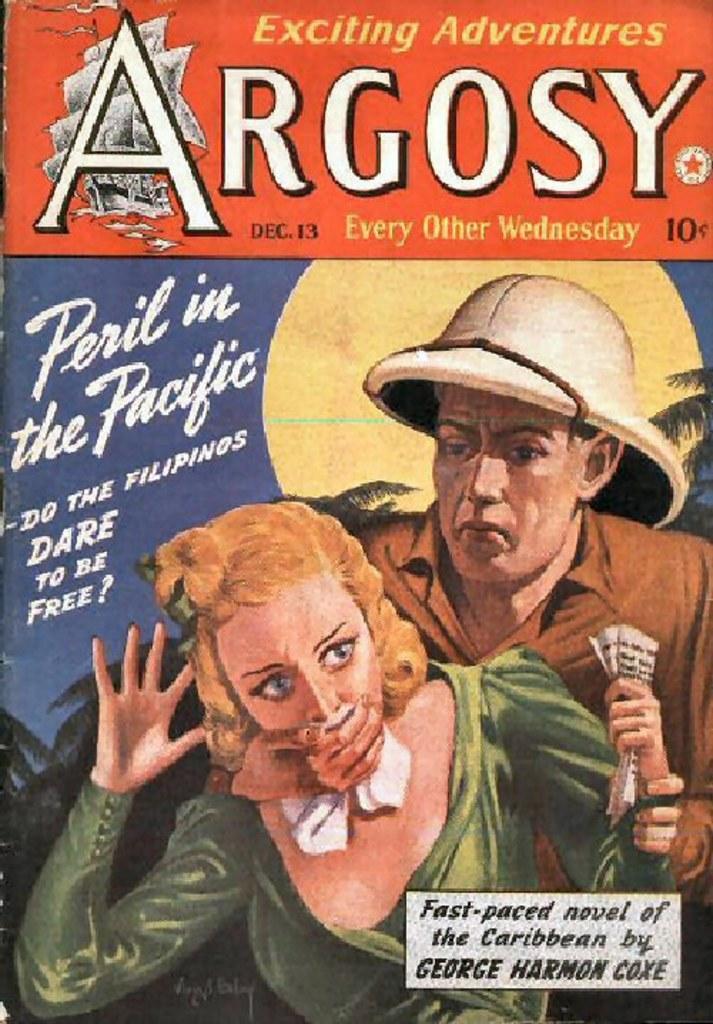Could you give a brief overview of what you see in this image? In this picture we can see the cover photo of the book. In the front we can see a man holding the woman and covering her face. On the top we can see "Argosy" is written. 